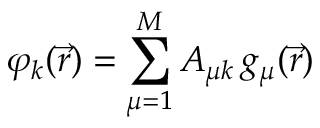Convert formula to latex. <formula><loc_0><loc_0><loc_500><loc_500>\varphi _ { k } ( \vec { r } ) = \sum _ { \mu = 1 } ^ { M } A _ { \mu k } \, g _ { \mu } ( \vec { r } )</formula> 